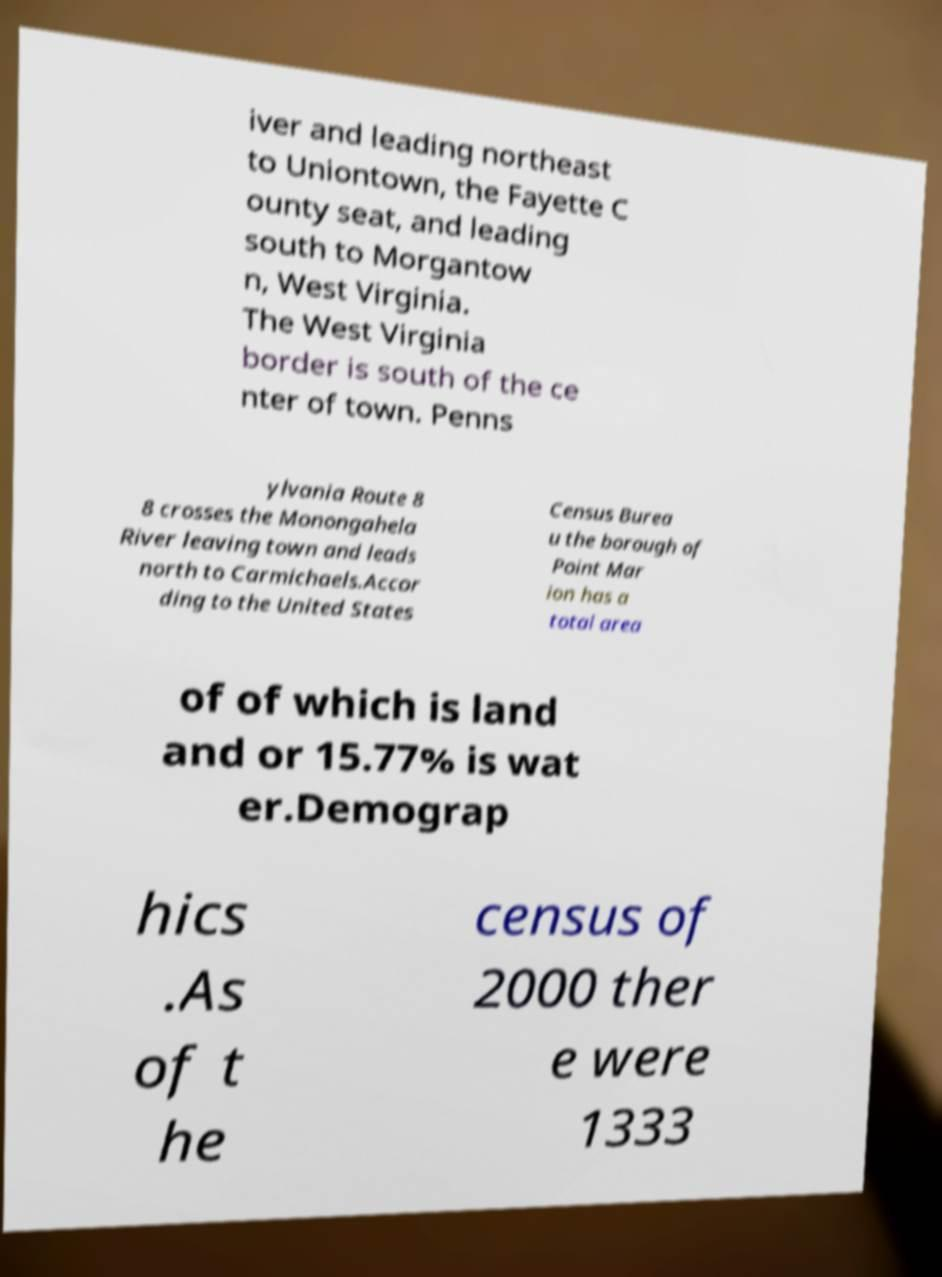Can you read and provide the text displayed in the image?This photo seems to have some interesting text. Can you extract and type it out for me? iver and leading northeast to Uniontown, the Fayette C ounty seat, and leading south to Morgantow n, West Virginia. The West Virginia border is south of the ce nter of town. Penns ylvania Route 8 8 crosses the Monongahela River leaving town and leads north to Carmichaels.Accor ding to the United States Census Burea u the borough of Point Mar ion has a total area of of which is land and or 15.77% is wat er.Demograp hics .As of t he census of 2000 ther e were 1333 